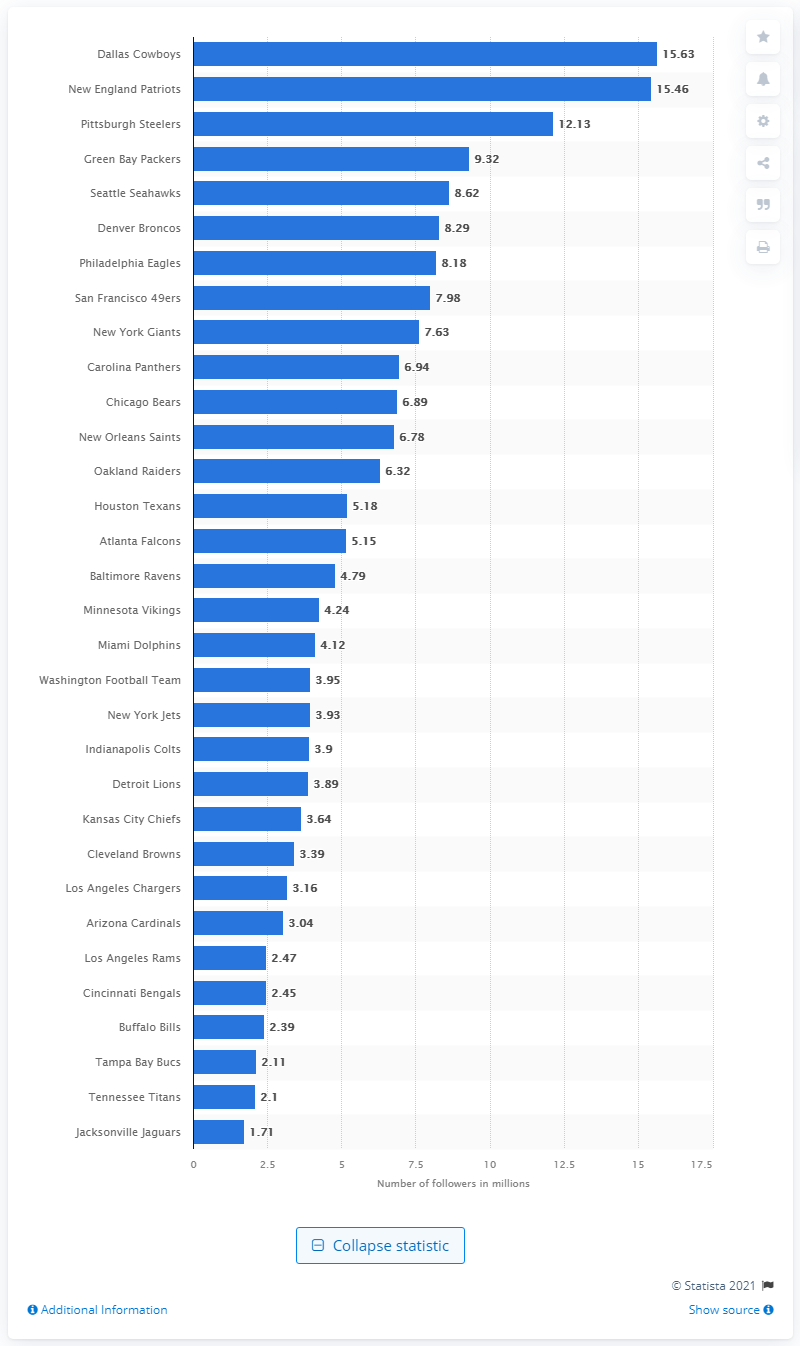List a handful of essential elements in this visual. In 2019, the Dallas Cowboys had 15.63 million followers worldwide. 